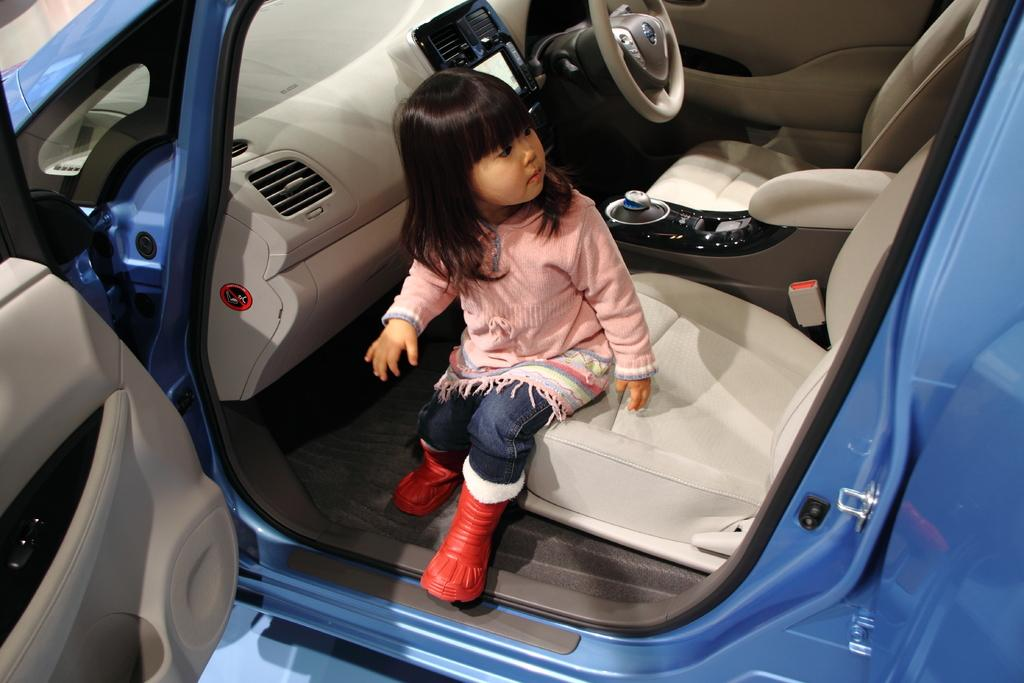Where was the image taken? The image is taken inside a car. What color is the car? The car is blue in color. Who is present in the car? There is a girl sitting in the car. What is the status of the car door on the left side? The car door is open on the left side. Can you see any fog in the image? There is no fog visible in the image, as it is taken inside a car. What type of station is present in the image? There is no station present in the image; it is taken inside a car. 